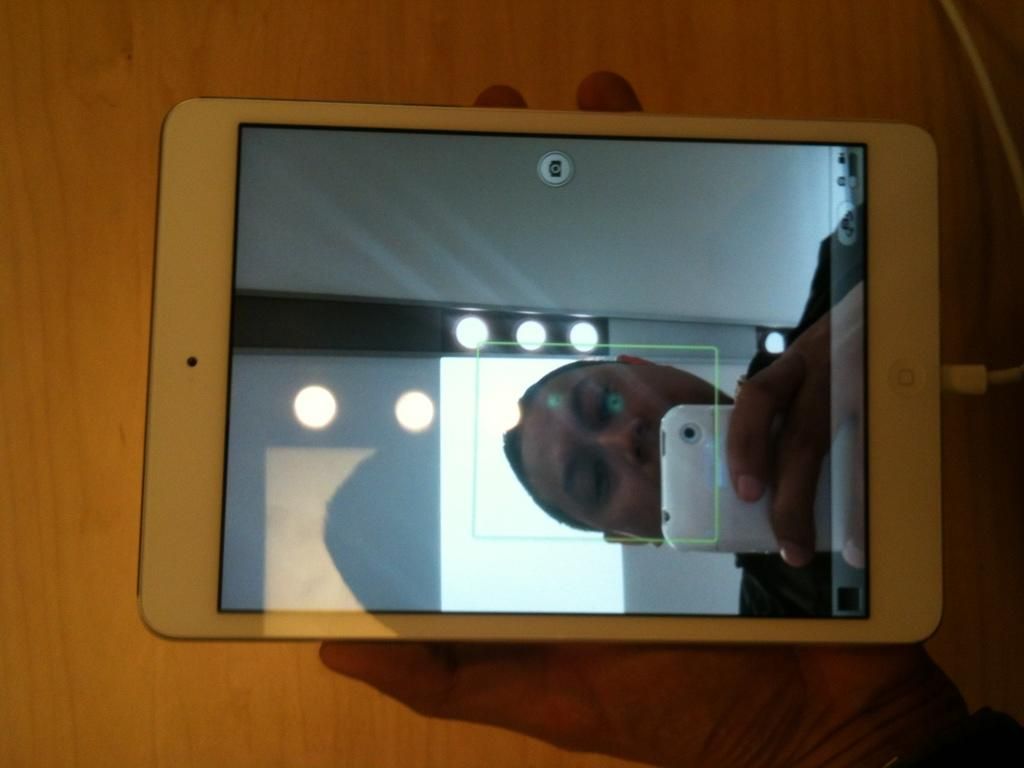Who is present in the image? There is a man in the image. What is the man holding in his hand? The man is holding a mobile phone in his hand. What part of the mobile phone is visible in the image? The display screen of the mobile phone is visible. What type of string is attached to the man's mobile phone in the image? There is no string attached to the man's mobile phone in the image. 